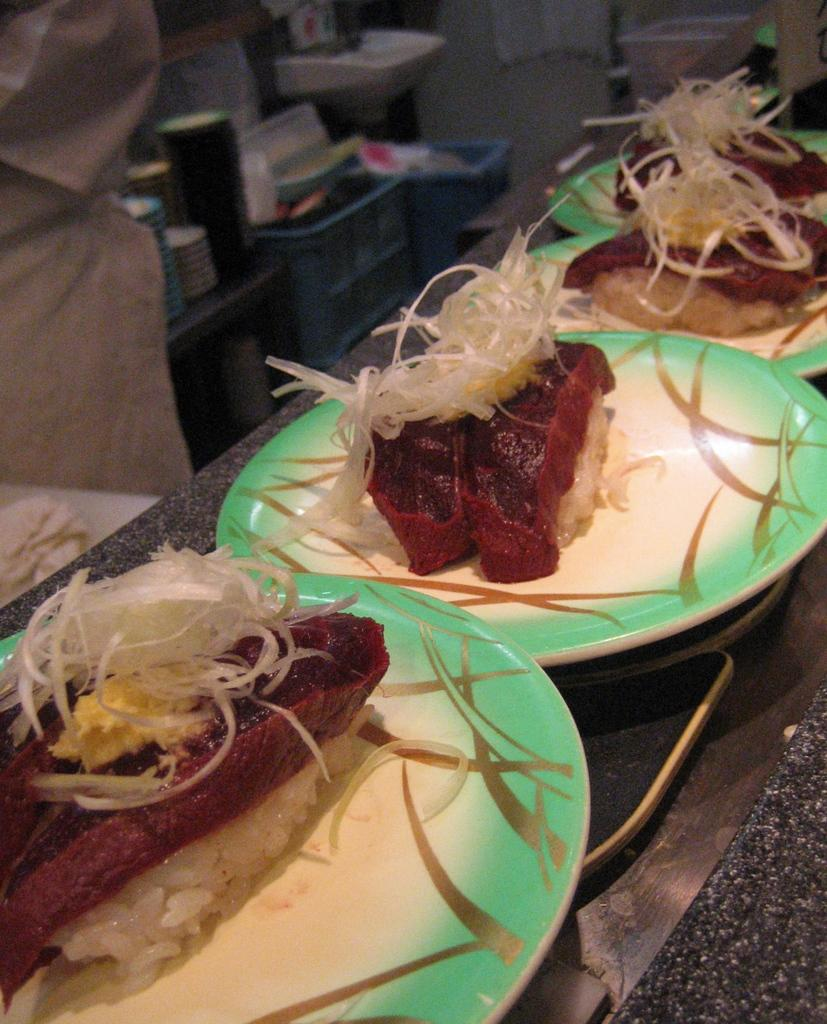What is on the plate that is visible in the image? There are food items in a plate in the image. Where is the plate located in the image? The plate is placed on a table in the image. What can be seen on the left side of the image? There are objects on the left side of the image. What type of horn is being played by the mother in the image? There is no mother or horn present in the image. 